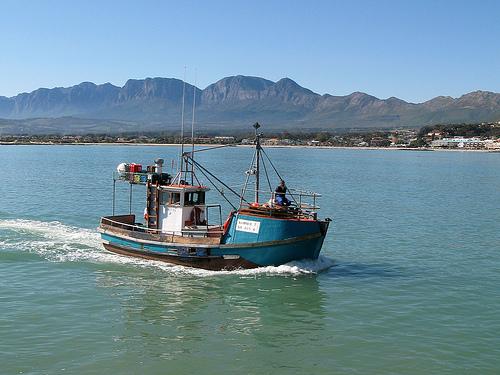Are there any ducks in the water?
Quick response, please. No. Is the boat green?
Short answer required. No. What color is the boat?
Answer briefly. Blue. Is it a pretty day?
Keep it brief. Yes. Does this boat have a motor?
Answer briefly. Yes. Is it an overcast day?
Concise answer only. No. What color is the water?
Answer briefly. Blue. 